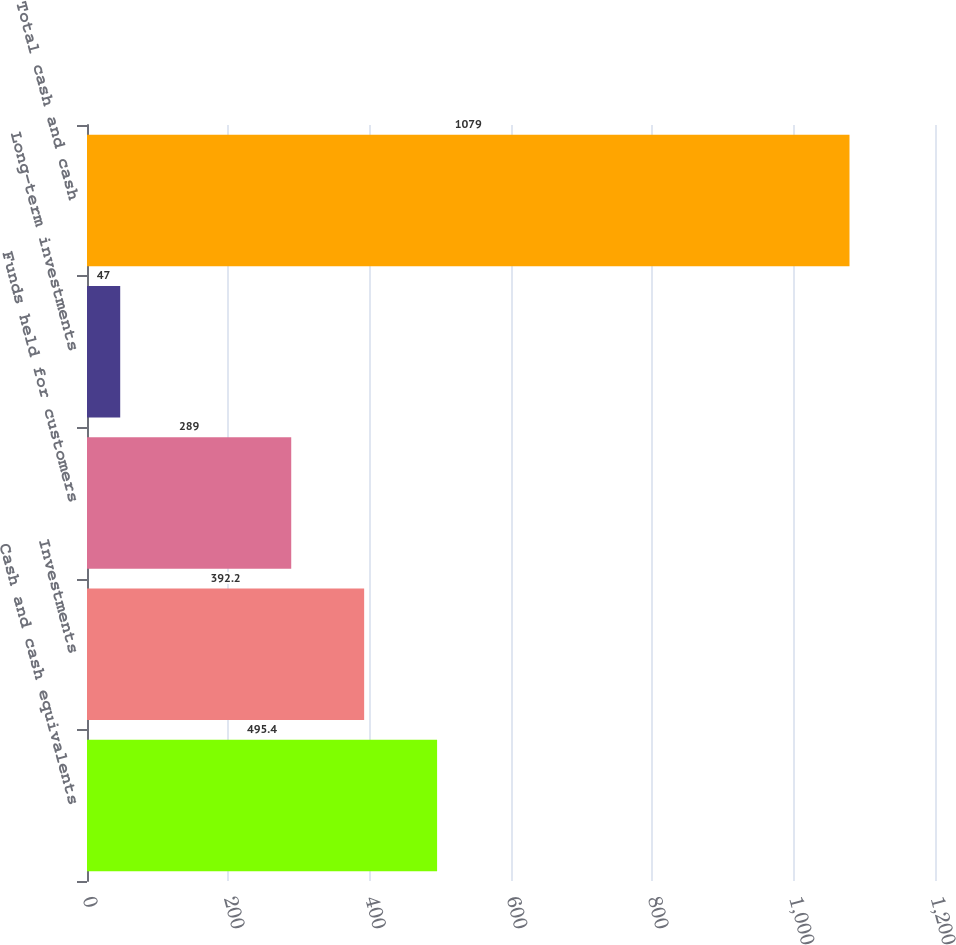Convert chart. <chart><loc_0><loc_0><loc_500><loc_500><bar_chart><fcel>Cash and cash equivalents<fcel>Investments<fcel>Funds held for customers<fcel>Long-term investments<fcel>Total cash and cash<nl><fcel>495.4<fcel>392.2<fcel>289<fcel>47<fcel>1079<nl></chart> 